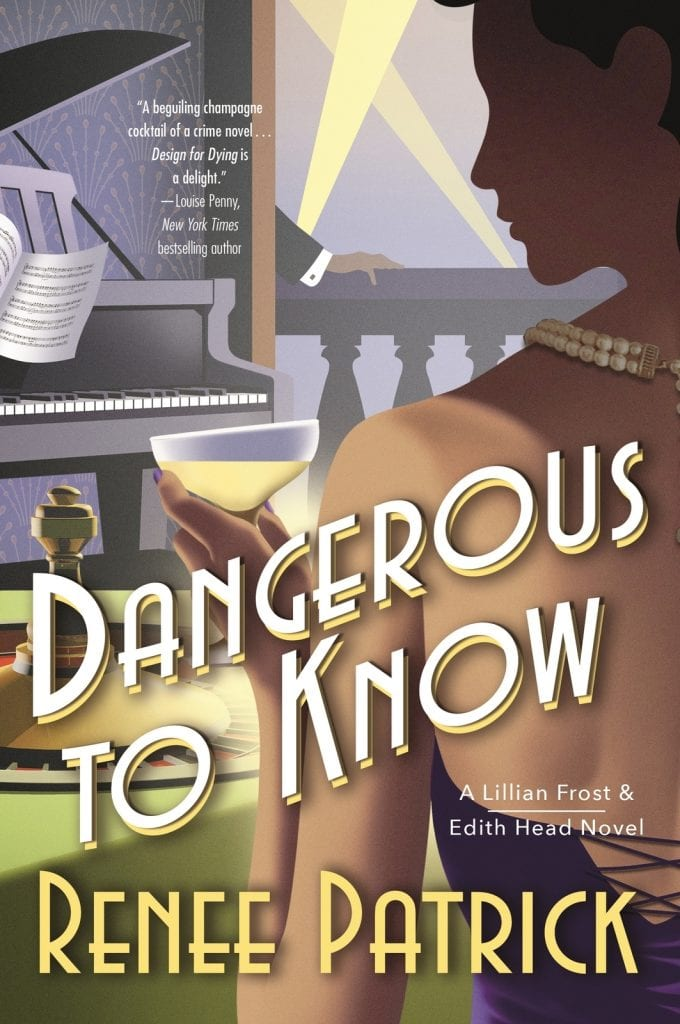What can you infer about the main themes of the book based on its cover design? The main themes of the book as suggested by the cover likely revolve around mystery and societal drama. The opulent setting combined with the mysterious tones indicate a narrative filled with elegance and possibly hidden dilemmas or crimes that unfold in a setting associated with wealth and prestige. 